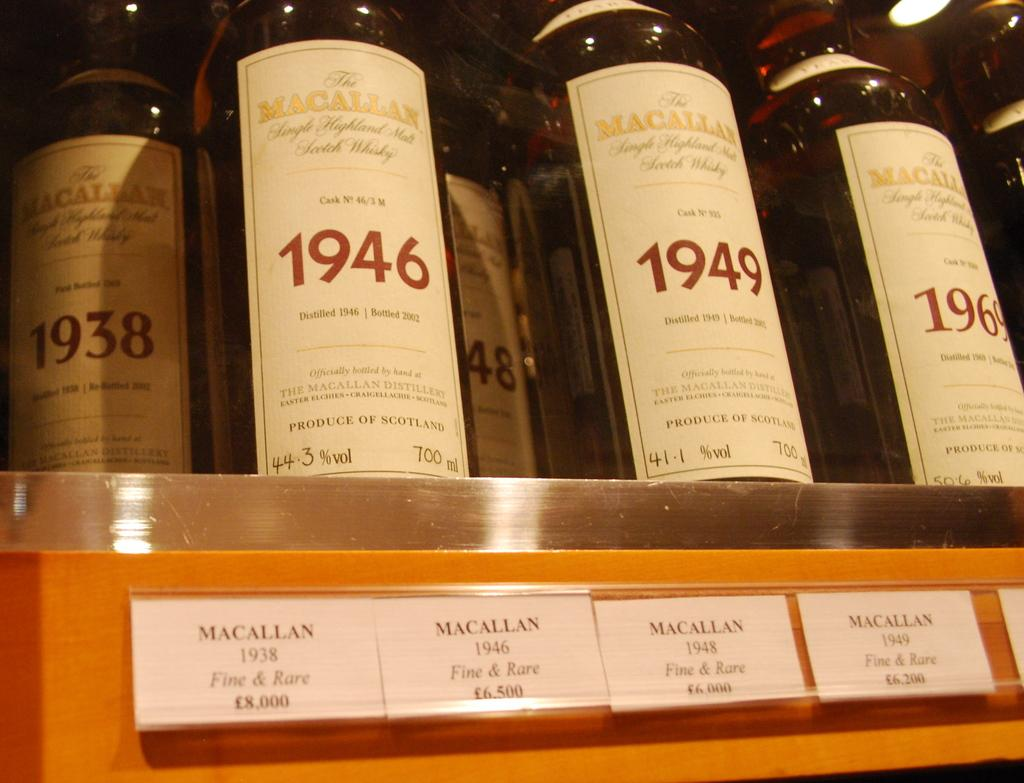<image>
Share a concise interpretation of the image provided. Four bottles of MaCallan Scotch Whiskey are lined up on a shelf with a brief description of the year and type of beverage it is. 